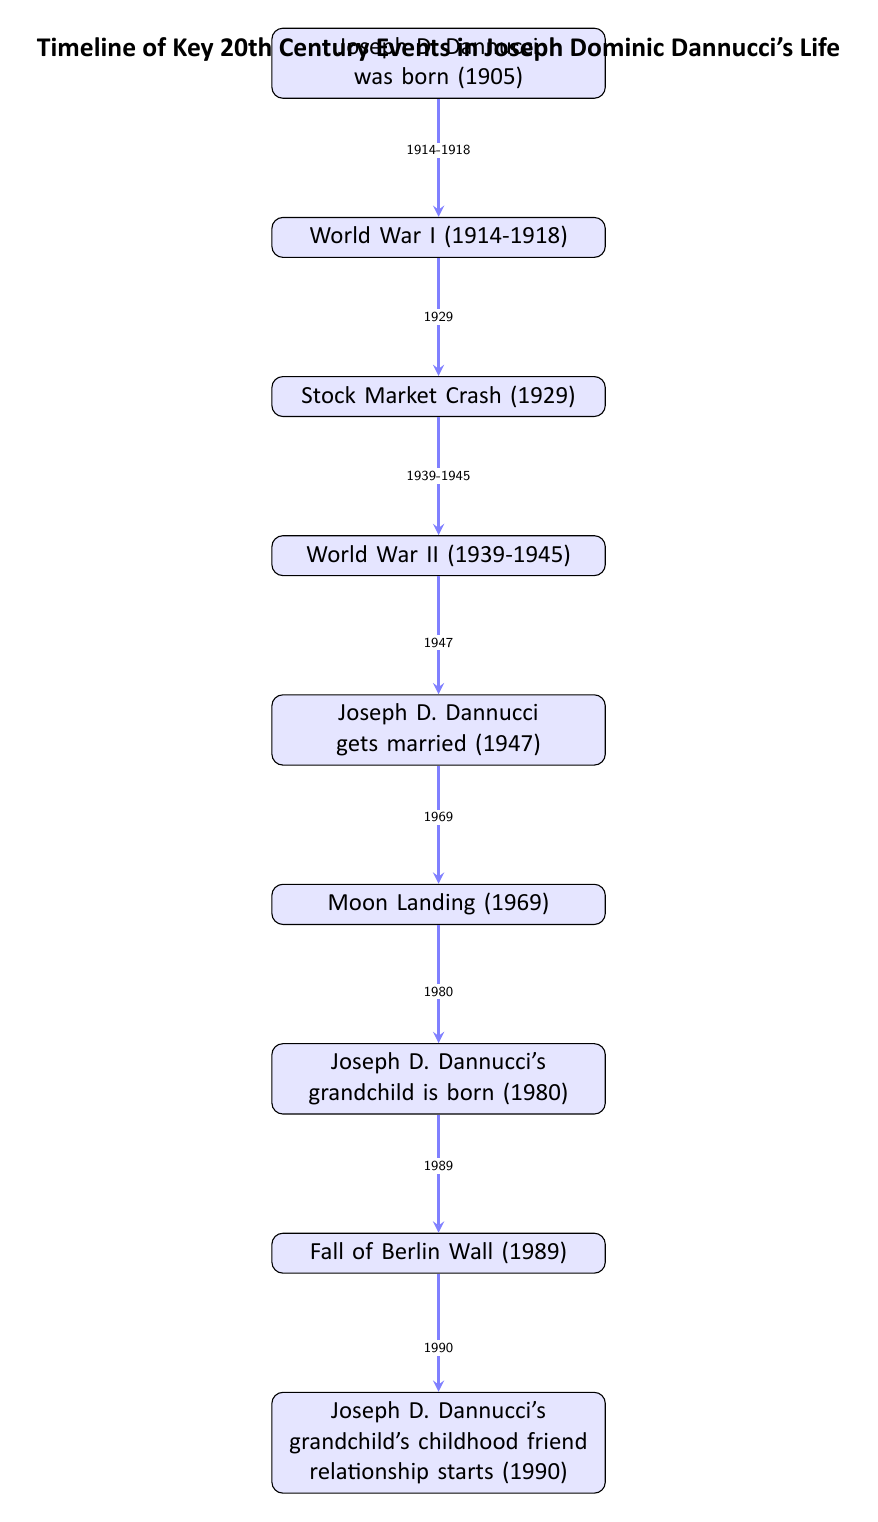What year was Joseph D. Dannucci born? The diagram shows the first node which states "Joseph D. Dannucci was born (1905)", indicating that he was born in the year 1905.
Answer: 1905 What major global conflict occurred between 1914 and 1918? The second node in the diagram indicates "World War I (1914-1918)", clearly identifying that World War I took place during this time.
Answer: World War I What event occurred immediately after Joseph D. Dannucci's marriage? According to the diagram, Joseph D. Dannucci gets married in 1947, and the following event listed is "Moon Landing (1969)", indicating that this event occurred next.
Answer: Moon Landing In what year did Joseph D. Dannucci's grandchild get born? The seventh node in the diagram indicates that "Joseph D. Dannucci's grandchild is born (1980)", directly providing the year of birth.
Answer: 1980 What is the sequence of events from Joseph D. Dannucci's birth to the moon landing? To answer this, we start with his birth in 1905, followed by World War I (1914-1918), the Stock Market Crash (1929), World War II (1939-1945), his marriage in 1947, and finally the Moon Landing in 1969. This shows the chronological flow of events connecting them all.
Answer: 1905, 1914-1918, 1929, 1939-1945, 1947, 1969 How many key events in Joseph D. Dannucci's life are shown in the diagram? By counting the nodes from Joseph’s birth until the last noted event, there are a total of 9 distinct events listed, from his birth to his grandchild's friend relationship.
Answer: 9 What major societal change is indicated by the event that occurred in 1989? The diagram shows "Fall of Berlin Wall (1989)" as the event linked above Joseph D. Dannucci's grandchild’s friendship, indicating a critical societal change marked by the fall of the Berlin Wall.
Answer: Fall of Berlin Wall Which event happened in 1990 according to the diagram? The last node in the timeline clearly illustrates "Joseph D. Dannucci's grandchild's childhood friend relationship starts (1990)", marking this as the event occurring in that year.
Answer: Joseph D. Dannucci's grandchild's childhood friend relationship starts 